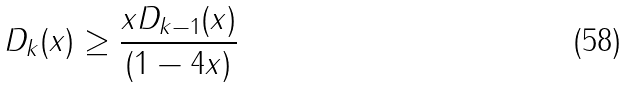<formula> <loc_0><loc_0><loc_500><loc_500>D _ { k } ( x ) \geq \frac { x D _ { k - 1 } ( x ) } { ( 1 - 4 x ) }</formula> 